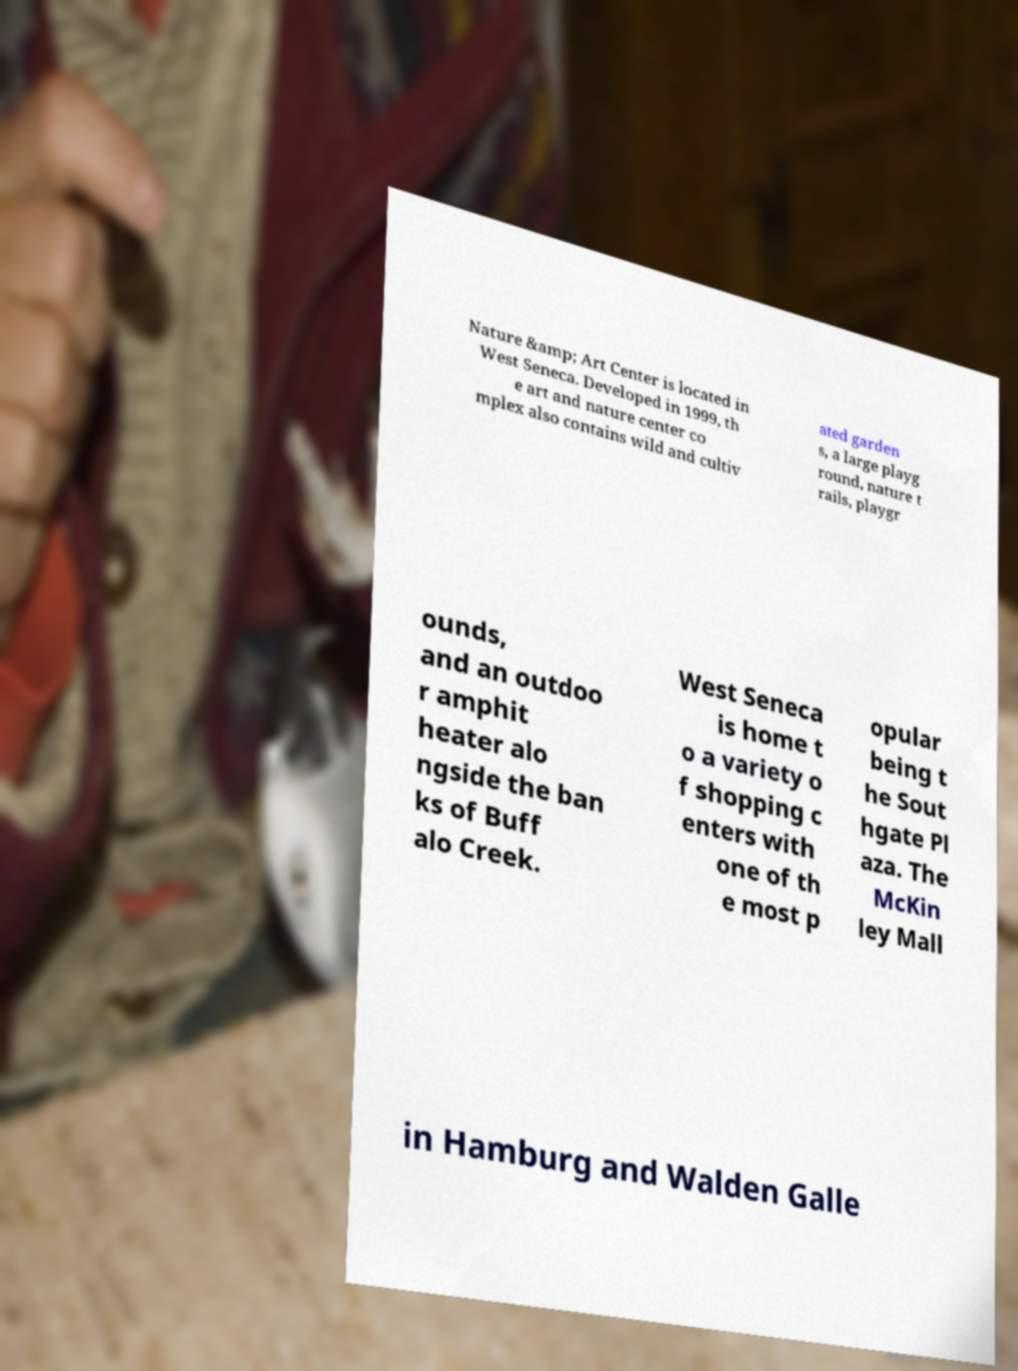Can you read and provide the text displayed in the image?This photo seems to have some interesting text. Can you extract and type it out for me? Nature &amp; Art Center is located in West Seneca. Developed in 1999, th e art and nature center co mplex also contains wild and cultiv ated garden s, a large playg round, nature t rails, playgr ounds, and an outdoo r amphit heater alo ngside the ban ks of Buff alo Creek. West Seneca is home t o a variety o f shopping c enters with one of th e most p opular being t he Sout hgate Pl aza. The McKin ley Mall in Hamburg and Walden Galle 